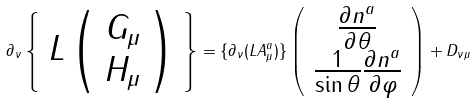<formula> <loc_0><loc_0><loc_500><loc_500>\partial _ { \nu } \left \{ \begin{array} { c } L \left ( \begin{array} { c } G _ { \mu } \\ H _ { \mu } \end{array} \right ) \end{array} \right \} = \{ \partial _ { \nu } ( L A ^ { a } _ { \mu } ) \} \left ( \begin{array} { c } \frac { \partial n ^ { a } } { \partial \theta } \\ \frac { 1 } { \sin \theta } \frac { \partial n ^ { a } } { \partial \varphi } \end{array} \right ) + D _ { \nu \mu }</formula> 